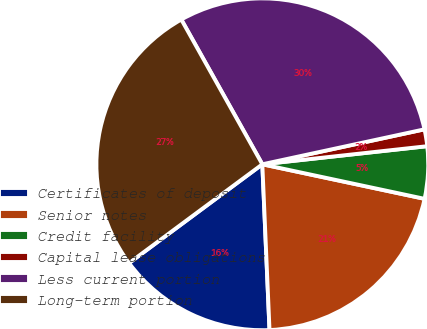Convert chart. <chart><loc_0><loc_0><loc_500><loc_500><pie_chart><fcel>Certificates of deposit<fcel>Senior notes<fcel>Credit facility<fcel>Capital lease obligations<fcel>Less current portion<fcel>Long-term portion<nl><fcel>15.54%<fcel>20.97%<fcel>5.08%<fcel>1.64%<fcel>29.74%<fcel>27.03%<nl></chart> 